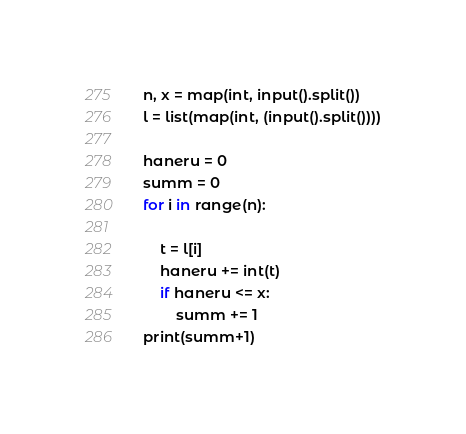<code> <loc_0><loc_0><loc_500><loc_500><_Python_>n, x = map(int, input().split())
l = list(map(int, (input().split())))

haneru = 0
summ = 0
for i in range(n):

    t = l[i]
    haneru += int(t)
    if haneru <= x:
        summ += 1
print(summ+1)</code> 